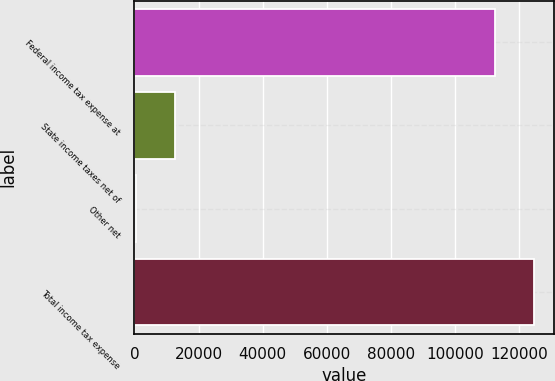Convert chart to OTSL. <chart><loc_0><loc_0><loc_500><loc_500><bar_chart><fcel>Federal income tax expense at<fcel>State income taxes net of<fcel>Other net<fcel>Total income tax expense<nl><fcel>112360<fcel>12527.6<fcel>365<fcel>124523<nl></chart> 